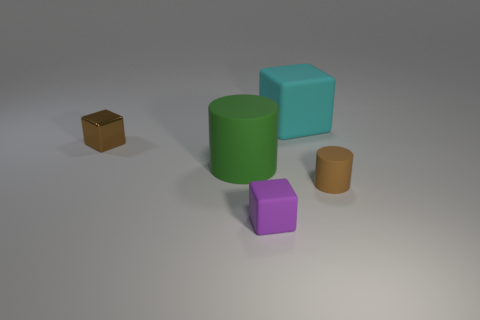How many big green cylinders have the same material as the big cyan object?
Offer a very short reply. 1. Does the cyan matte cube have the same size as the green object?
Ensure brevity in your answer.  Yes. The small metal object is what color?
Make the answer very short. Brown. What number of things are big green rubber objects or brown rubber objects?
Ensure brevity in your answer.  2. Is there a brown shiny thing that has the same shape as the green thing?
Make the answer very short. No. Do the small thing behind the tiny brown cylinder and the tiny cylinder have the same color?
Keep it short and to the point. Yes. The small object that is right of the purple matte cube that is in front of the big rubber cylinder is what shape?
Provide a succinct answer. Cylinder. Is there another thing that has the same size as the purple thing?
Your answer should be compact. Yes. Are there fewer tiny brown cylinders than large purple spheres?
Offer a terse response. No. What shape is the large matte object that is in front of the tiny brown object that is behind the large matte thing that is in front of the cyan rubber cube?
Make the answer very short. Cylinder. 